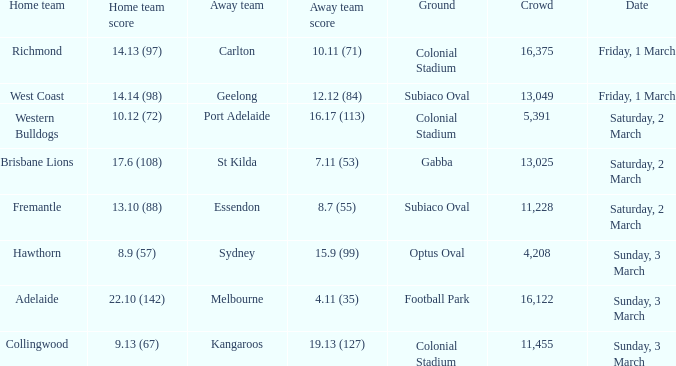What was the basis for the away team essendon? Subiaco Oval. 